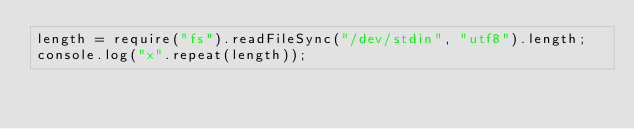Convert code to text. <code><loc_0><loc_0><loc_500><loc_500><_JavaScript_>length = require("fs").readFileSync("/dev/stdin", "utf8").length;
console.log("x".repeat(length));</code> 